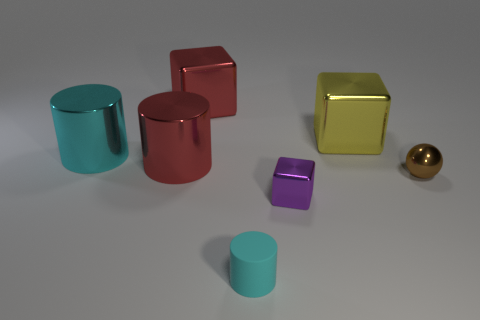Subtract all cyan balls. Subtract all green cylinders. How many balls are left? 1 Add 2 purple cubes. How many objects exist? 9 Subtract all cubes. How many objects are left? 4 Add 2 big yellow shiny cubes. How many big yellow shiny cubes exist? 3 Subtract 0 yellow balls. How many objects are left? 7 Subtract all big brown rubber cubes. Subtract all cyan rubber cylinders. How many objects are left? 6 Add 4 tiny purple cubes. How many tiny purple cubes are left? 5 